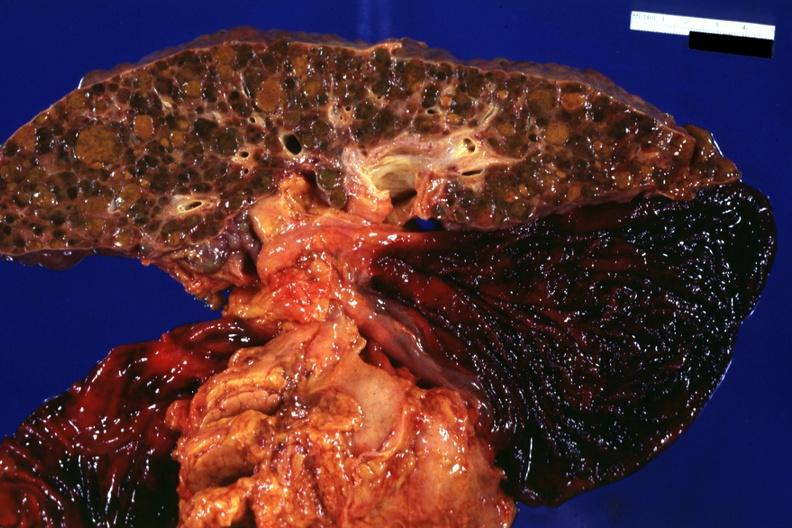s hepatobiliary present?
Answer the question using a single word or phrase. Yes 